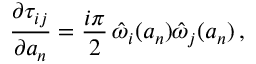<formula> <loc_0><loc_0><loc_500><loc_500>{ \frac { \partial \tau _ { i j } } { \partial a _ { n } } } = { \frac { i \pi } { 2 } } \, \hat { \omega } _ { i } ( a _ { n } ) \hat { \omega } _ { j } ( a _ { n } ) \, ,</formula> 